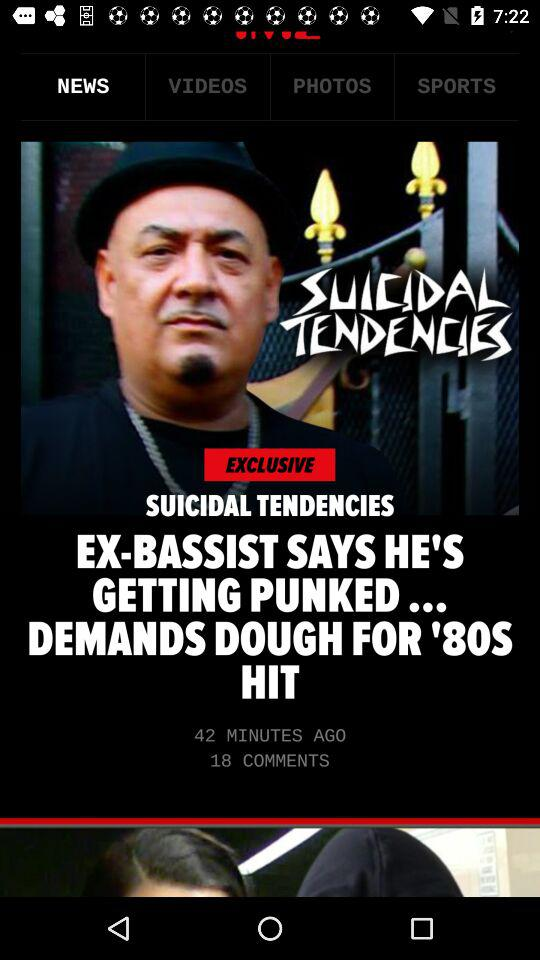How many minutes ago the news Suicidal Tendencies is updated?
When the provided information is insufficient, respond with <no answer>. <no answer> 